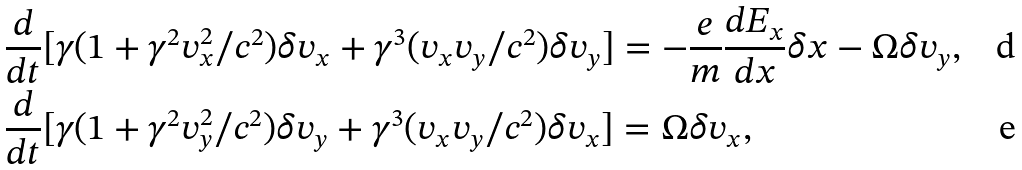<formula> <loc_0><loc_0><loc_500><loc_500>& \frac { d } { d t } [ \gamma ( 1 + \gamma ^ { 2 } v _ { x } ^ { 2 } / c ^ { 2 } ) \delta v _ { x } + \gamma ^ { 3 } ( v _ { x } v _ { y } / c ^ { 2 } ) \delta v _ { y } ] = - \frac { e } { m } \frac { d E _ { x } } { d x } \delta x - \Omega \delta v _ { y } , \\ & \frac { d } { d t } [ \gamma ( 1 + \gamma ^ { 2 } v _ { y } ^ { 2 } / c ^ { 2 } ) \delta v _ { y } + \gamma ^ { 3 } ( v _ { x } v _ { y } / c ^ { 2 } ) \delta v _ { x } ] = \Omega \delta v _ { x } ,</formula> 